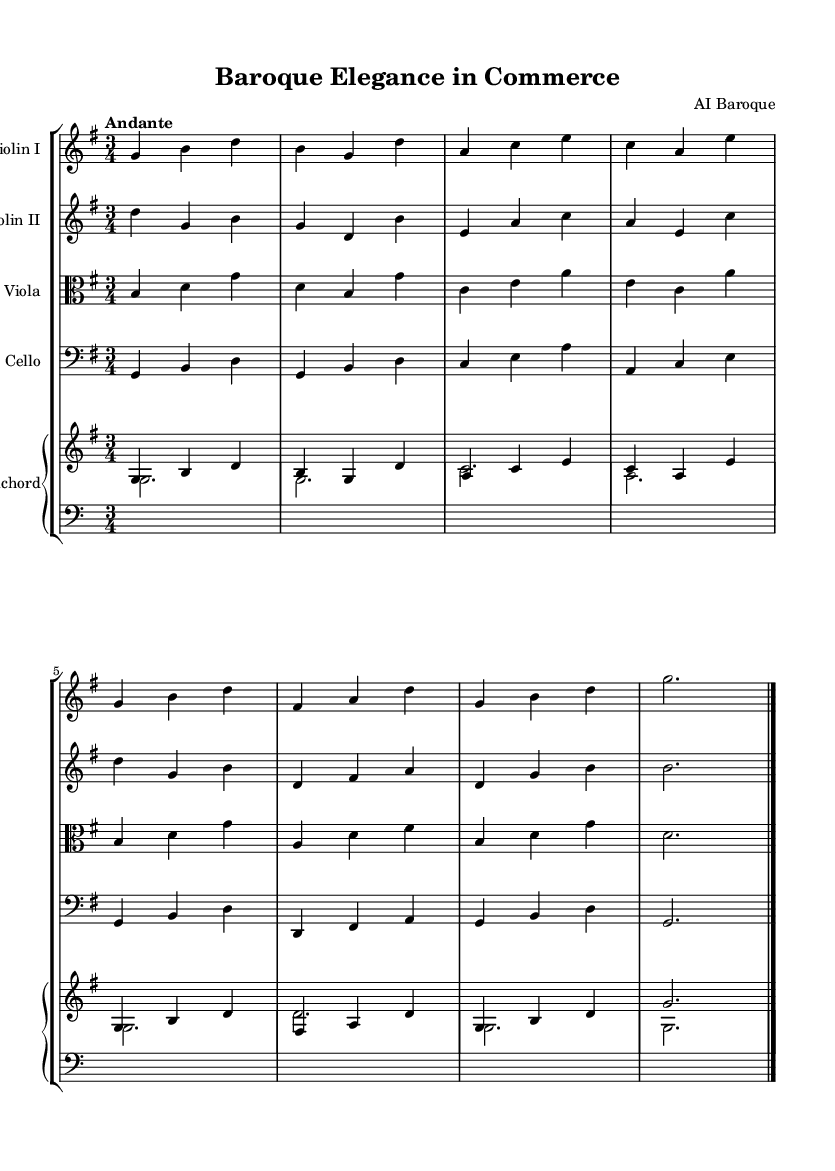What is the key signature of this music? The key signature is indicated at the beginning of the staff, showing one sharp which corresponds to G major.
Answer: G major What is the time signature of this music? The time signature is shown at the beginning as a "3/4", which means each measure has three beats, and a quarter note receives one beat.
Answer: 3/4 What is the tempo marking of this music? The tempo marking is written above the staff, indicating "Andante", which suggests a moderately slow tempo.
Answer: Andante How many instruments are in this composition? By counting the distinct staffs in the score, we find there are five instruments: two violins, one viola, one cello, and one harpsichord.
Answer: Five What is the role of the harpsichord in this composition? The harpsichord has two staves: the upper staff plays the melody and harmonies, while the lower staff includes bass clef notes, supporting the harmonic structure.
Answer: Melody and bass Are there any repeated notes in Violin I? In the Violin I part, the note G is repeated in the first and fifth measures, indicating a common melodic figure in Baroque music.
Answer: Yes Which compositional technique is prominent in this piece? The piece features counterpoint, where different instruments play independent melodies that complement each other, typical of Baroque music.
Answer: Counterpoint 